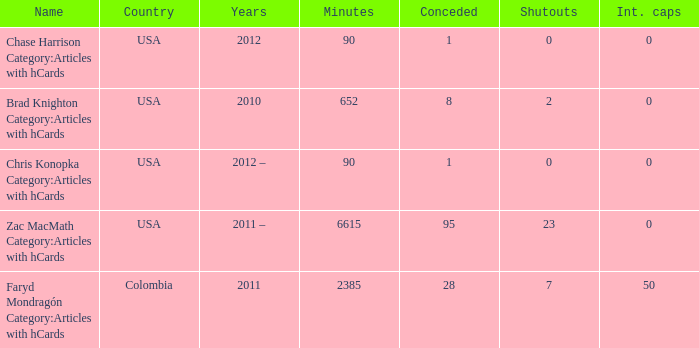When chase harrison category:articles with hcards is the name what is the year? 2012.0. 